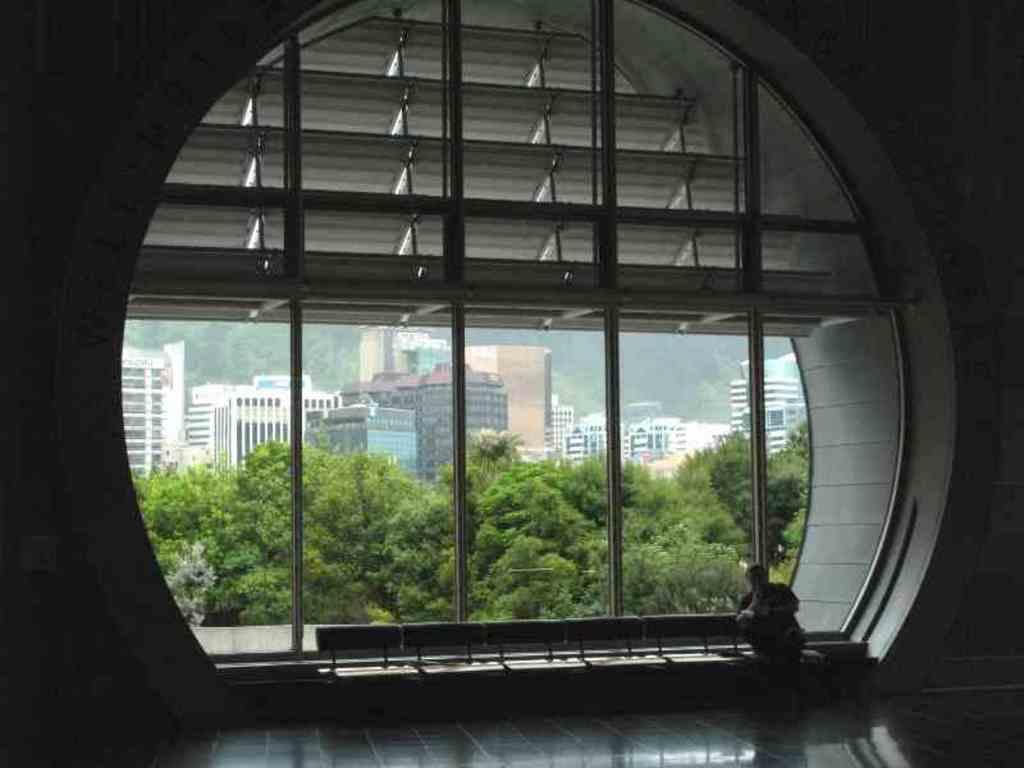Where was the image taken? The image is taken indoors. Can you describe the person on the right side of the image? Unfortunately, the facts provided do not give any information about the person's appearance or clothing. What can be seen through the window in the image? The sky, buildings, and trees are visible through the window in the image. What is the background of the image made of? The background of the image includes a wall. What type of jam is being spread on the cent in the image? There is no cent or jam present in the image. What color is the person's hair on the right side of the image? Unfortunately, the facts provided do not give any information about the person's hair color. 